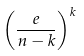Convert formula to latex. <formula><loc_0><loc_0><loc_500><loc_500>\left ( \frac { e } { n - k } \right ) ^ { k }</formula> 